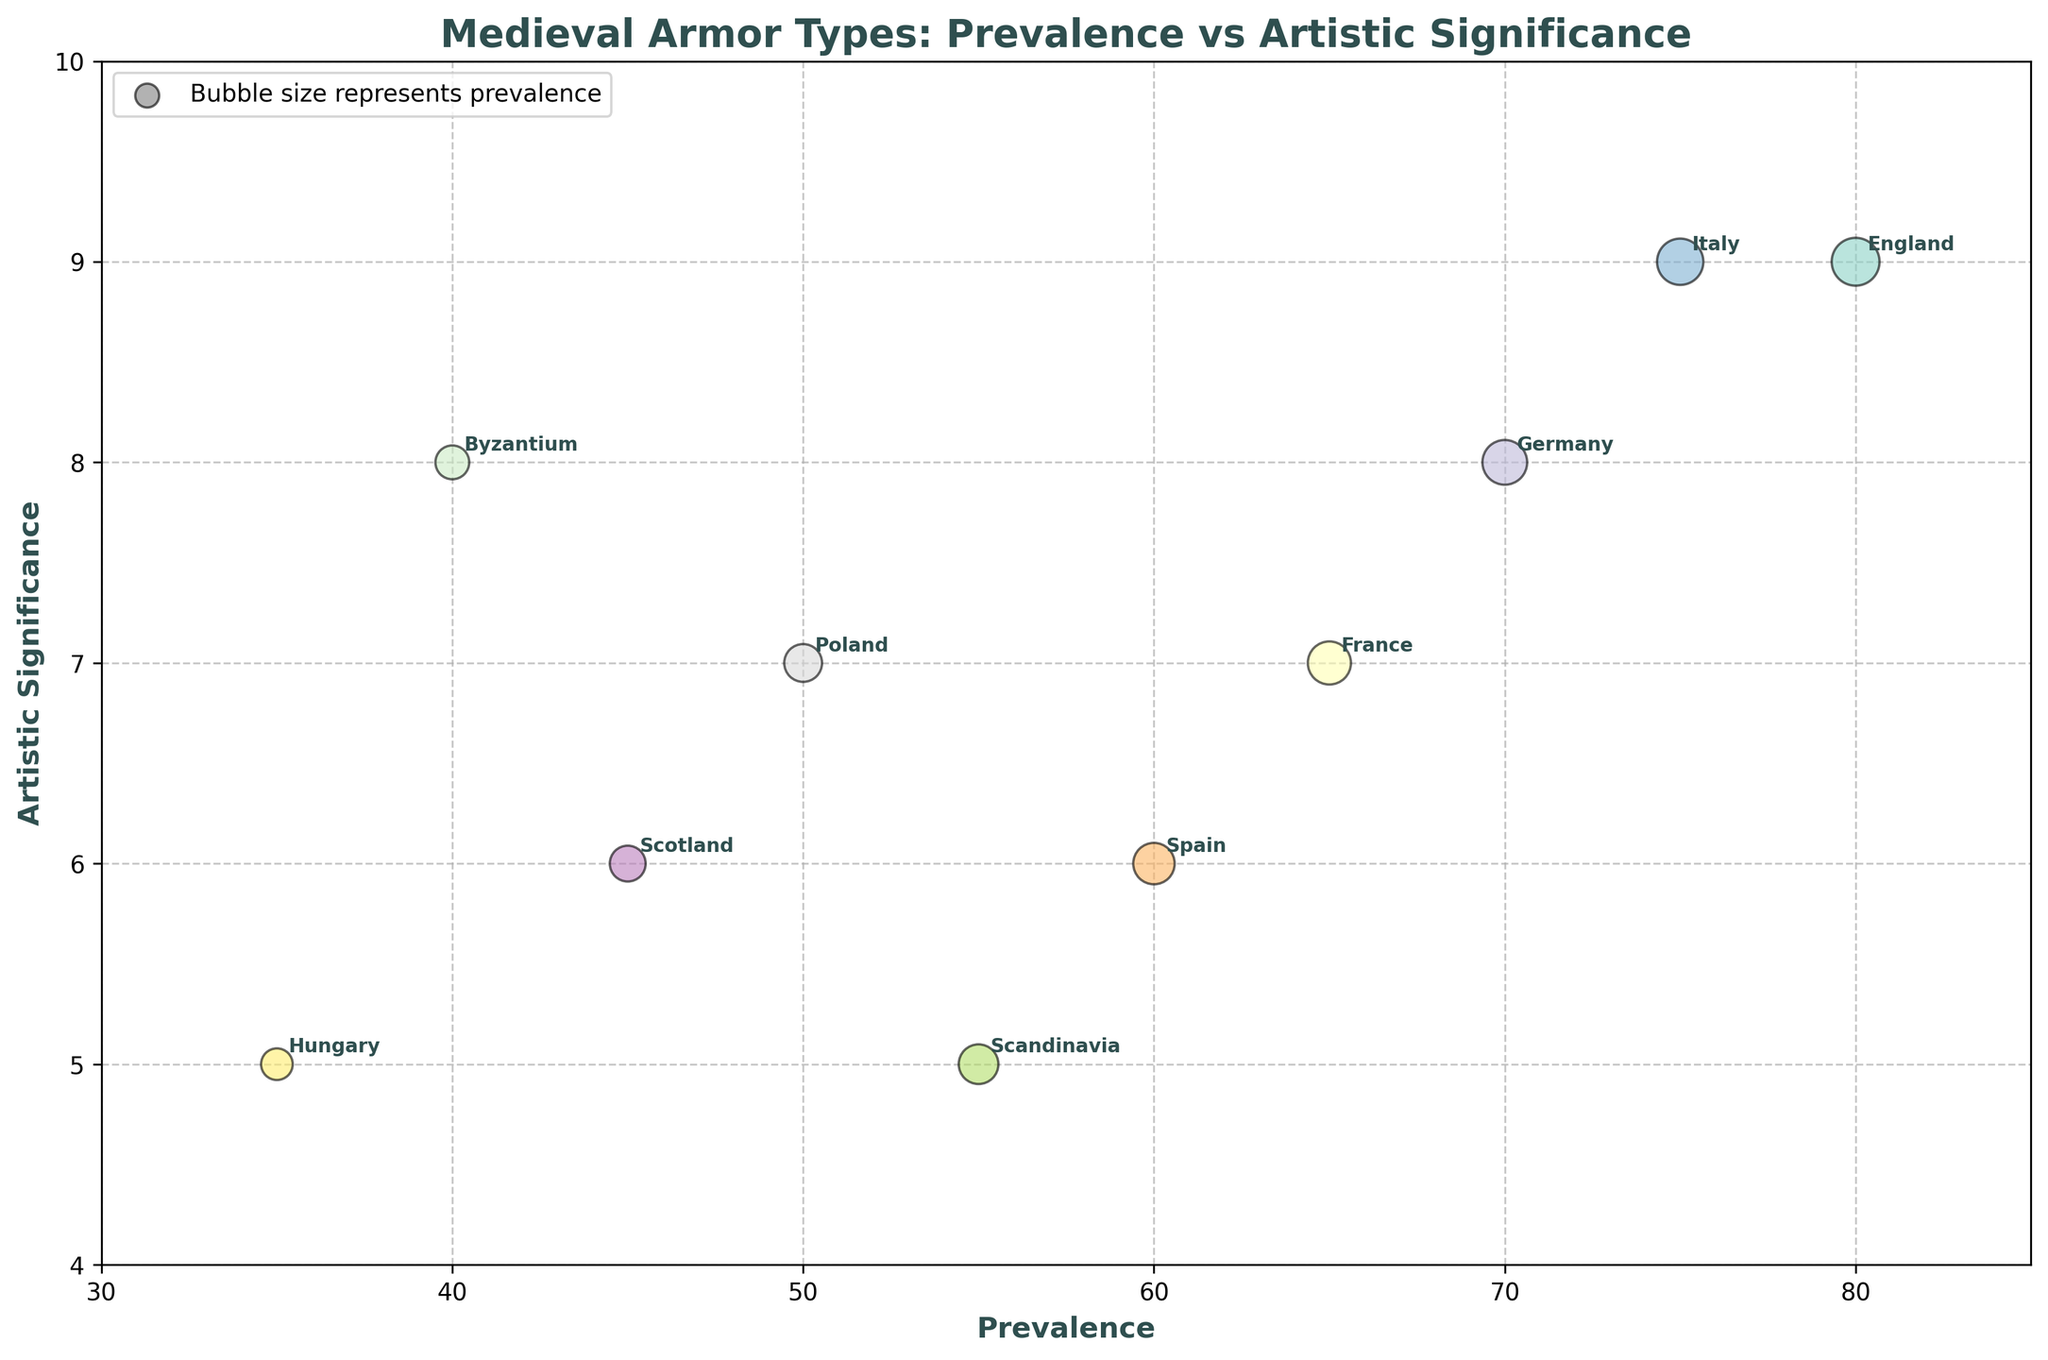What's the title of the figure? The title of the figure is displayed prominently at the top of the plot.
Answer: Medieval Armor Types: Prevalence vs Artistic Significance How many different regions are represented in the plot? Each point on the plot corresponds to a different region. Count the annotations to determine the number of regions.
Answer: 10 Which region has the armor with the highest artistic significance? Look for the point positioned at the highest value on the y-axis (Artistic Significance).
Answer: England What is the armor material for the region with the lowest prevalence? Find the region with the lowest x-axis value (Prevalence), which is Hungary. Then, refer to the matching material.
Answer: Bronze and Leather Which region has a higher artistic significance, Germany or Byzantium? Compare the y-axis values for the points labeled Germany and Byzantium.
Answer: Germany What is the total prevalence of all the steel armors combined? Identify all points where the material is Steel: England, Germany, Italy, Spain, and Poland. Sum their prevalence values. 80 + 70 + 75 + 60 + 50 = 335
Answer: 335 What is the average artistic significance of armors made of iron? Find the artistic significance for the iron materials: France and Scandinavia. Calculate the average: (7 + 5) / 2 = 6
Answer: 6 Which type of armor has the smallest bubble size on the plot? The smallest bubble correlates to the point with the smallest Prevalence value, which is Hungary's Scale Armor.
Answer: Scale Armor Is the prevalence of Mail Armor in France greater than the prevalence of Cataphract Armor in Byzantium? Compare the x-axis values for France (65) and Byzantium (40).
Answer: Yes What is the difference in artistic significance between the regions with the highest and lowest prevalence? The highest prevalence is in England (80, significance 9) and the lowest in Hungary (35, significance 5). Calculate the difference in artistic significance: 9 - 5 = 4
Answer: 4 